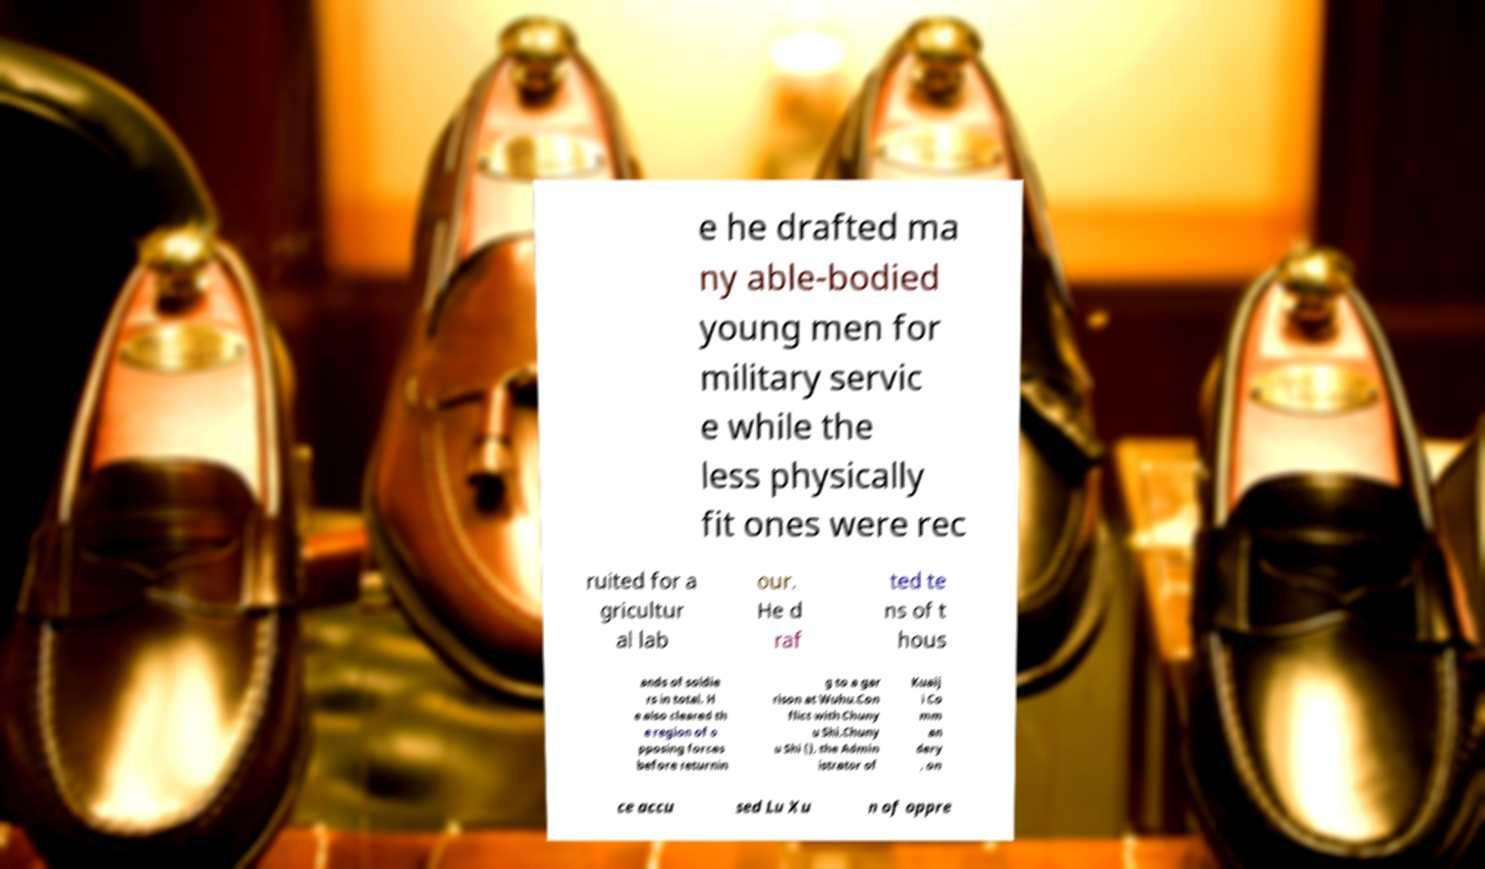For documentation purposes, I need the text within this image transcribed. Could you provide that? e he drafted ma ny able-bodied young men for military servic e while the less physically fit ones were rec ruited for a gricultur al lab our. He d raf ted te ns of t hous ands of soldie rs in total. H e also cleared th e region of o pposing forces before returnin g to a gar rison at Wuhu.Con flict with Chuny u Shi.Chuny u Shi (), the Admin istrator of Kuaij i Co mm an dery , on ce accu sed Lu Xu n of oppre 